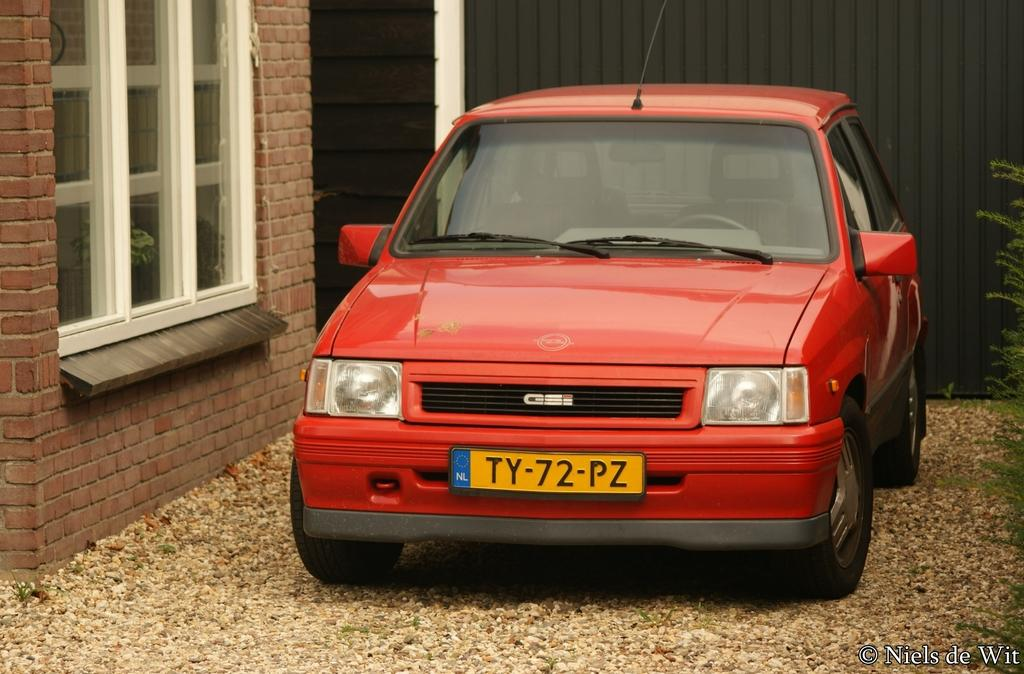What is the main subject in the center of the image? There is a car in the center of the image. What color is the car? The car is red in color. What else can be seen on the left side of the image? There is a window on the left side of the image. What type of creature is sitting in the driver's seat of the car? There is no creature visible in the image, and the driver's seat is not mentioned. 